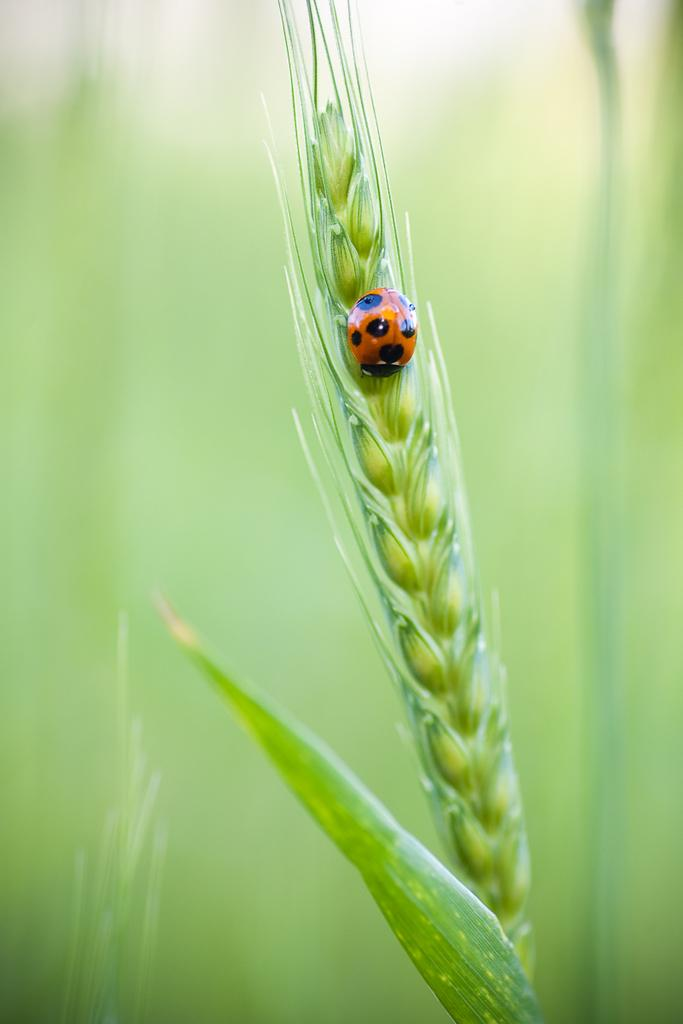What type of vegetation is present in the image? There is grass in the image. Can you describe any living organisms in the image? There is an insect on a plant in the image. What season is depicted in the image? The provided facts do not mention any specific season, so it cannot be determined from the image. 